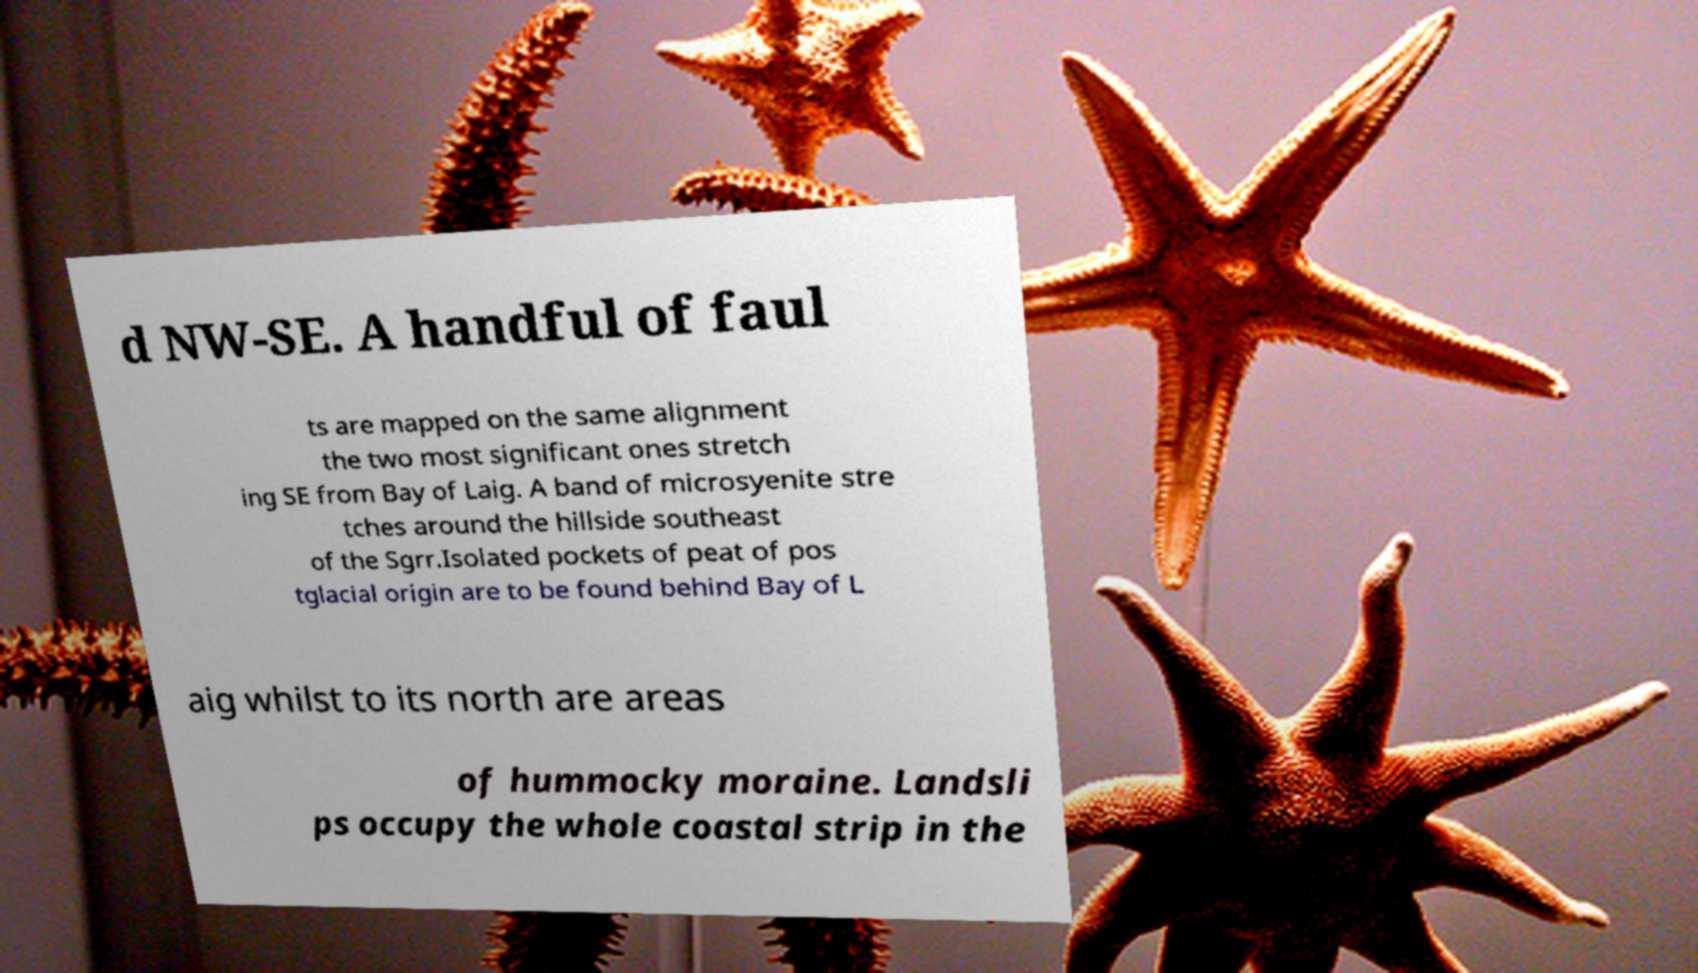Please read and relay the text visible in this image. What does it say? d NW-SE. A handful of faul ts are mapped on the same alignment the two most significant ones stretch ing SE from Bay of Laig. A band of microsyenite stre tches around the hillside southeast of the Sgrr.Isolated pockets of peat of pos tglacial origin are to be found behind Bay of L aig whilst to its north are areas of hummocky moraine. Landsli ps occupy the whole coastal strip in the 